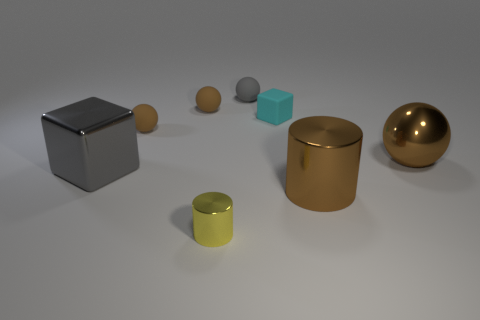Subtract all purple blocks. How many brown spheres are left? 3 Subtract 1 spheres. How many spheres are left? 3 Subtract all purple cylinders. Subtract all brown blocks. How many cylinders are left? 2 Add 2 cubes. How many objects exist? 10 Subtract all cylinders. How many objects are left? 6 Subtract all small green rubber objects. Subtract all small metal cylinders. How many objects are left? 7 Add 8 big spheres. How many big spheres are left? 9 Add 2 small brown balls. How many small brown balls exist? 4 Subtract 0 yellow cubes. How many objects are left? 8 